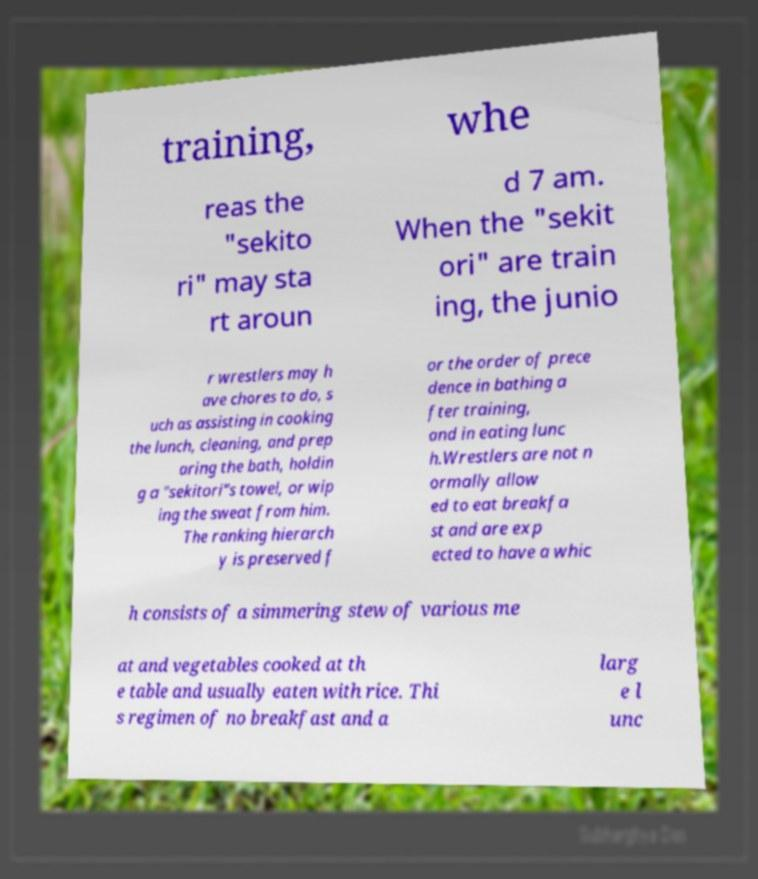I need the written content from this picture converted into text. Can you do that? training, whe reas the "sekito ri" may sta rt aroun d 7 am. When the "sekit ori" are train ing, the junio r wrestlers may h ave chores to do, s uch as assisting in cooking the lunch, cleaning, and prep aring the bath, holdin g a "sekitori"s towel, or wip ing the sweat from him. The ranking hierarch y is preserved f or the order of prece dence in bathing a fter training, and in eating lunc h.Wrestlers are not n ormally allow ed to eat breakfa st and are exp ected to have a whic h consists of a simmering stew of various me at and vegetables cooked at th e table and usually eaten with rice. Thi s regimen of no breakfast and a larg e l unc 